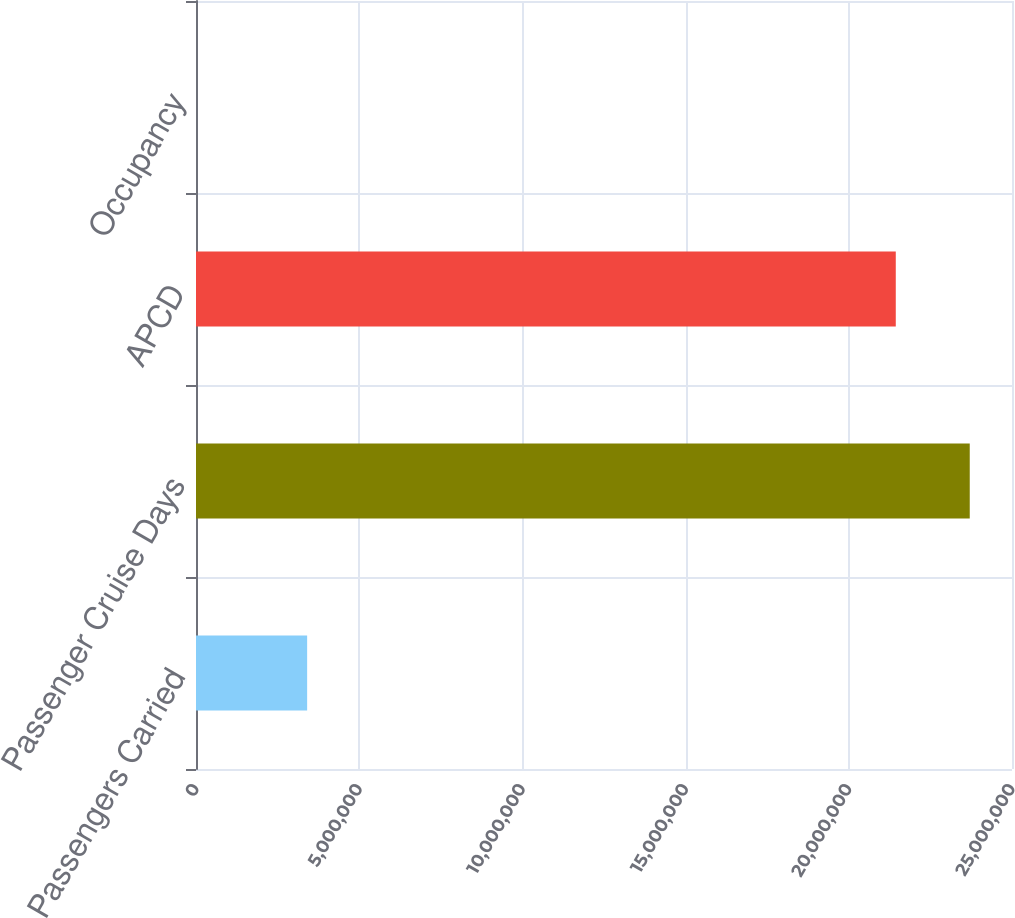<chart> <loc_0><loc_0><loc_500><loc_500><bar_chart><fcel>Passengers Carried<fcel>Passenger Cruise Days<fcel>APCD<fcel>Occupancy<nl><fcel>3.40523e+06<fcel>2.37055e+07<fcel>2.14393e+07<fcel>105.7<nl></chart> 